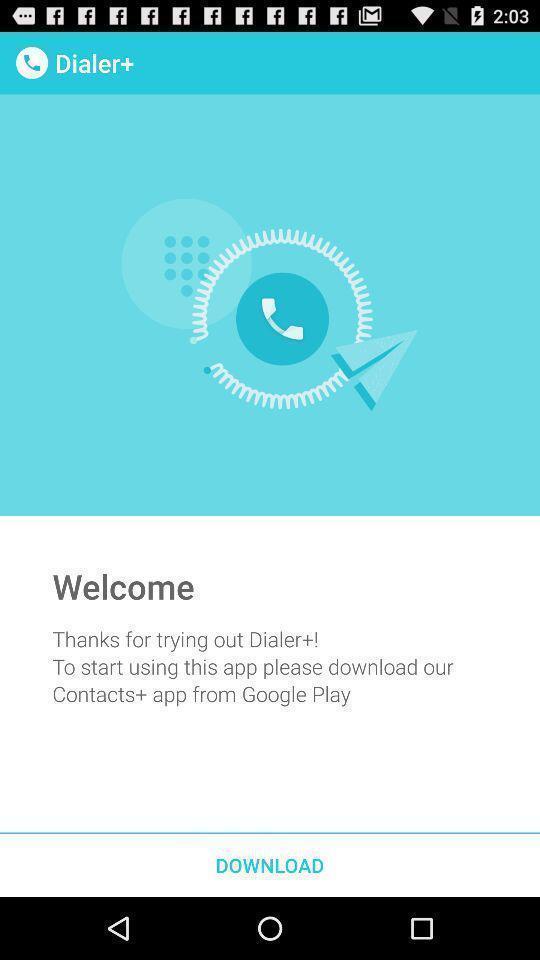Summarize the main components in this picture. Welcome page of the dialer option to download. 